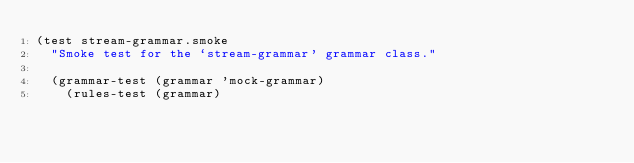<code> <loc_0><loc_0><loc_500><loc_500><_Lisp_>(test stream-grammar.smoke
  "Smoke test for the `stream-grammar' grammar class."

  (grammar-test (grammar 'mock-grammar)
    (rules-test (grammar)</code> 